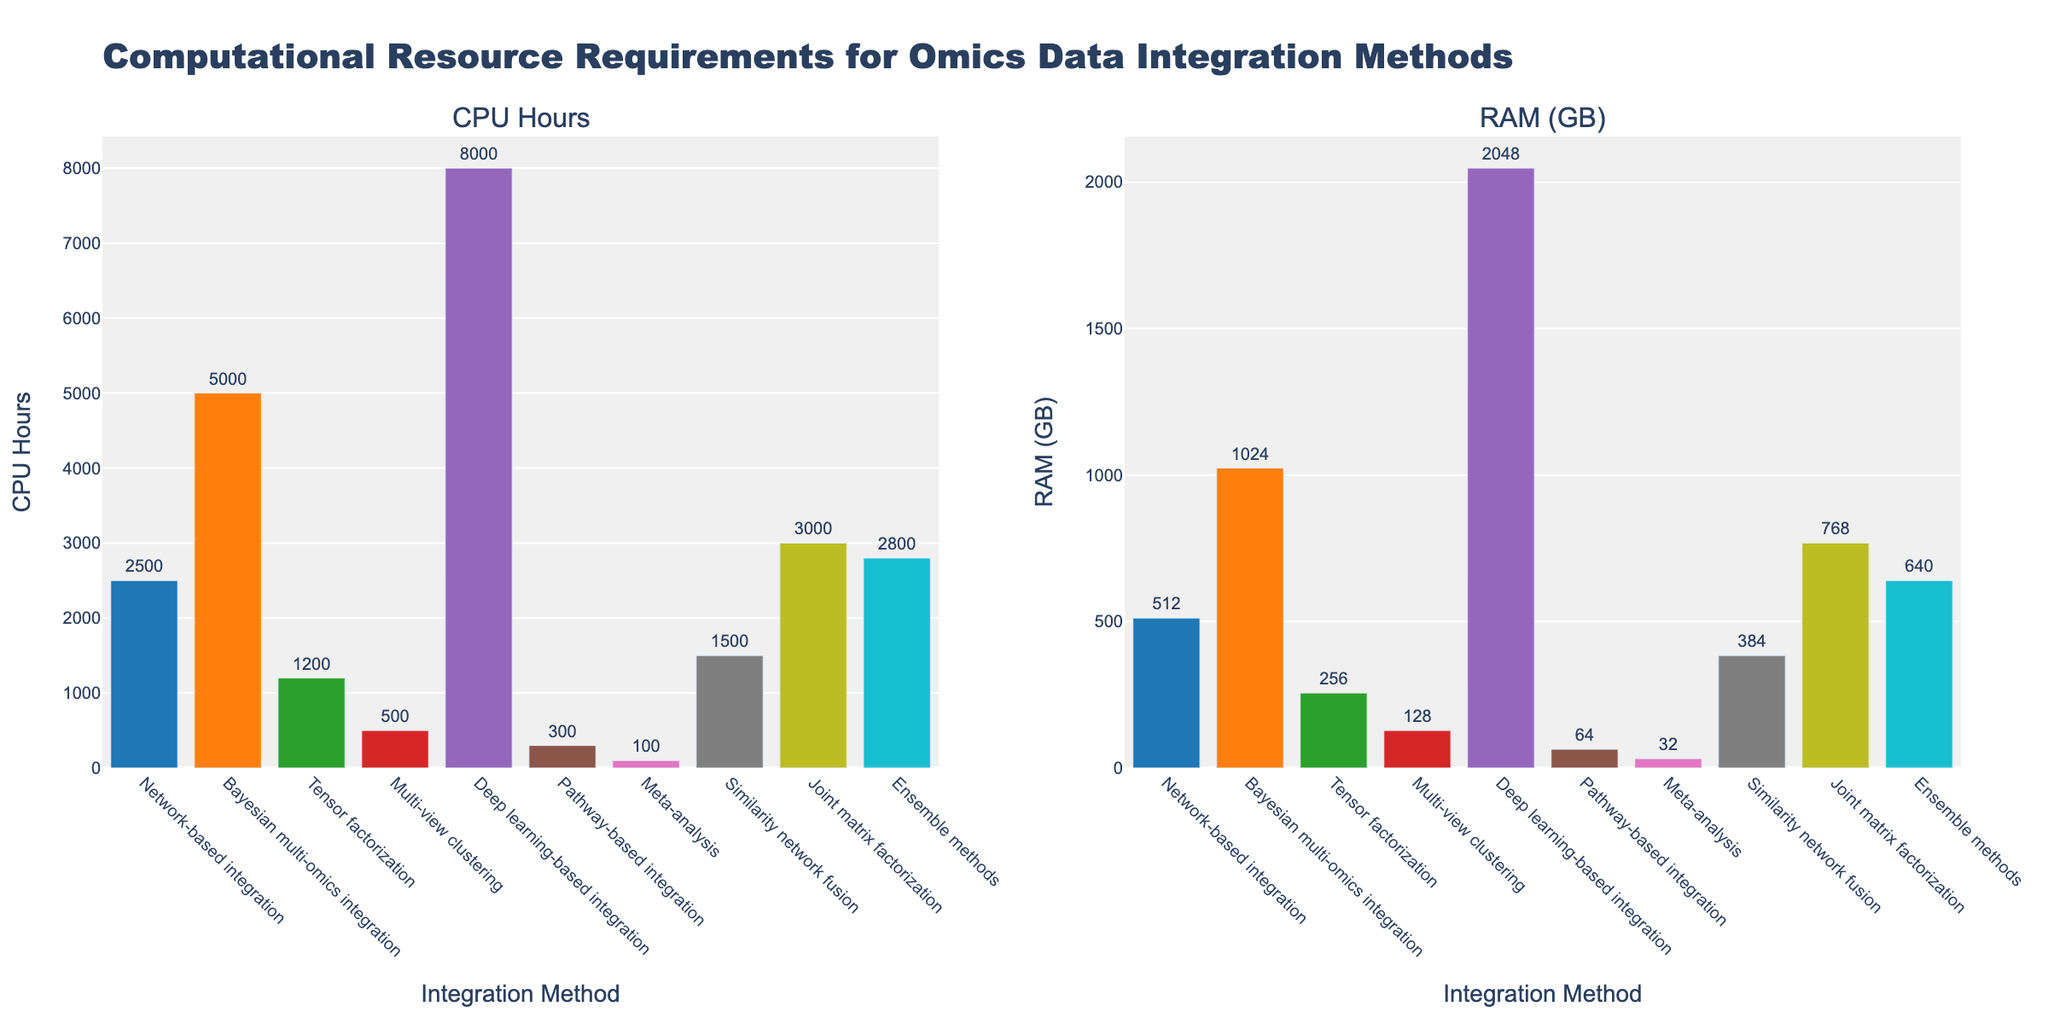Which integration method requires the most CPU hours? Look for the highest bar in the "CPU Hours" subplot. The integration method with the highest bar will be the one that requires the most CPU hours.
Answer: Deep learning-based integration Which method has the lowest RAM requirement? Look for the bar with the smallest height in the "RAM (GB)" subplot. The method associated with this bar has the lowest RAM requirement.
Answer: Meta-analysis How does the CPU hours requirement of the Bayesian multi-omics integration compare to the joint matrix factorization? Compare the heights of the bars for these two methods in the "CPU Hours" subplot. Bayesian multi-omics integration's bar is higher than the joint matrix factorization's bar, indicating it requires more CPU hours.
Answer: Bayesian multi-omics integration requires more CPU hours Which method integrating omics data with medium complexity uses the least RAM? Identify the bars in the "RAM (GB)" subplot associated with methods of medium complexity. Compare their heights, the one with the smallest height uses the least RAM.
Answer: Tensor factorization What is the combined RAM requirement for multi-view clustering and pathway-based integration methods? Find the RAM values for both methods and sum them up. Multi-view clustering requires 128 GB and pathway-based integration requires 64 GB. The sum is 128 + 64.
Answer: 192 GB Which has a greater discrepancy between CPU hours and RAM requirements: deep learning-based integration or network-based integration? For both methods, calculate the difference between CPU hours and RAM requirements. Deep learning-based integration: 8000 CPU hours vs. 2048 GB RAM. Network-based integration: 2500 CPU hours vs. 512 GB RAM. Compare the differences.
Answer: Deep learning-based integration Which method uses the second most CPU hours and how much is it? Sort the methods by CPU hours and find the second highest value. After deep learning-based integration (8000 CPU hours), the next highest is Bayesian multi-omics integration (5000 CPU hours).
Answer: Bayesian multi-omics integration, 5000 How many methods require more than 3000 CPU hours? Count the number of bars in the "CPU Hours" subplot that extend beyond the 3000 mark. There are four bars that meet this criterion.
Answer: 4 methods Among the methods with high data size (TB), which one uses the most RAM? Identify methods with high data size and compare their RAM requirements. Joint matrix factorization (768 GB) and ensemble methods (640 GB) both qualify, but Bayesian multi-omics integration stands out with 1024 GB.
Answer: Bayesian multi-omics integration Between tensor factorization and similarity network fusion, which method has a higher CPU hours requirement and by how much? Compare the CPU hours for both methods; tensor factorization requires 1200 CPU hours and similarity network fusion requires 1500 CPU hours. Calculate the difference.
Answer: Similarity network fusion, by 300 CPU hours 